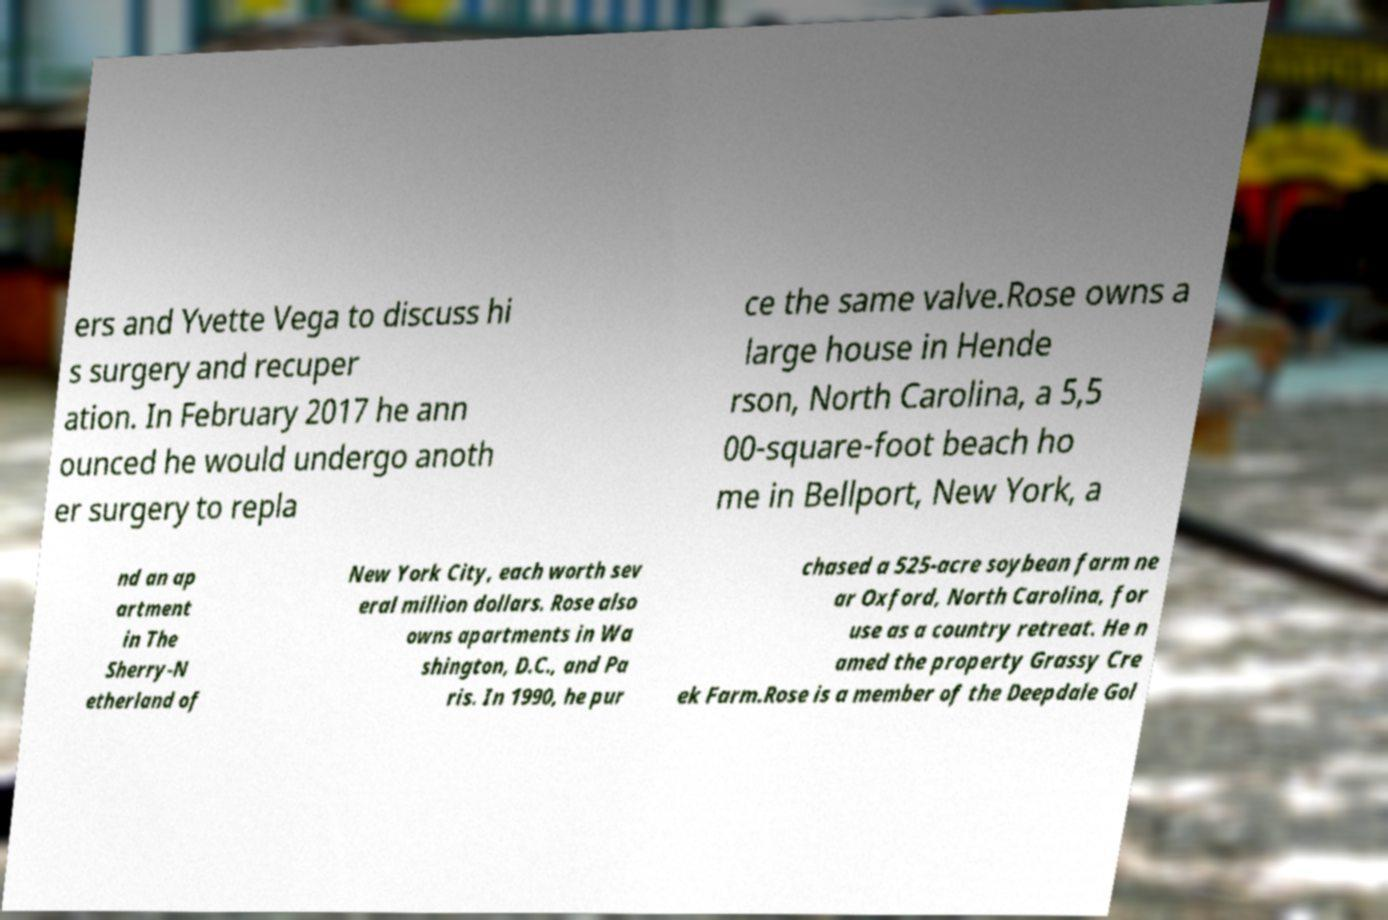Could you extract and type out the text from this image? ers and Yvette Vega to discuss hi s surgery and recuper ation. In February 2017 he ann ounced he would undergo anoth er surgery to repla ce the same valve.Rose owns a large house in Hende rson, North Carolina, a 5,5 00-square-foot beach ho me in Bellport, New York, a nd an ap artment in The Sherry-N etherland of New York City, each worth sev eral million dollars. Rose also owns apartments in Wa shington, D.C., and Pa ris. In 1990, he pur chased a 525-acre soybean farm ne ar Oxford, North Carolina, for use as a country retreat. He n amed the property Grassy Cre ek Farm.Rose is a member of the Deepdale Gol 